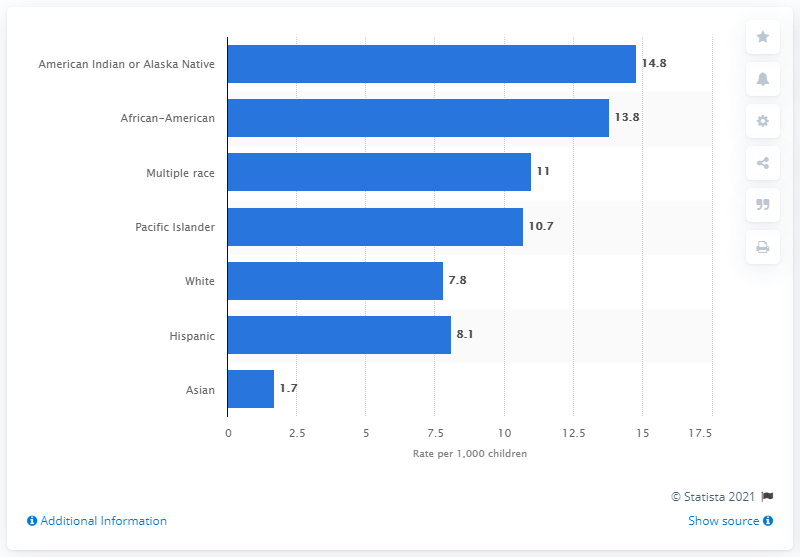Highlight a few significant elements in this photo. According to data from 2019, the rate of child abuse among children of Hispanic origin was 8.1%. 